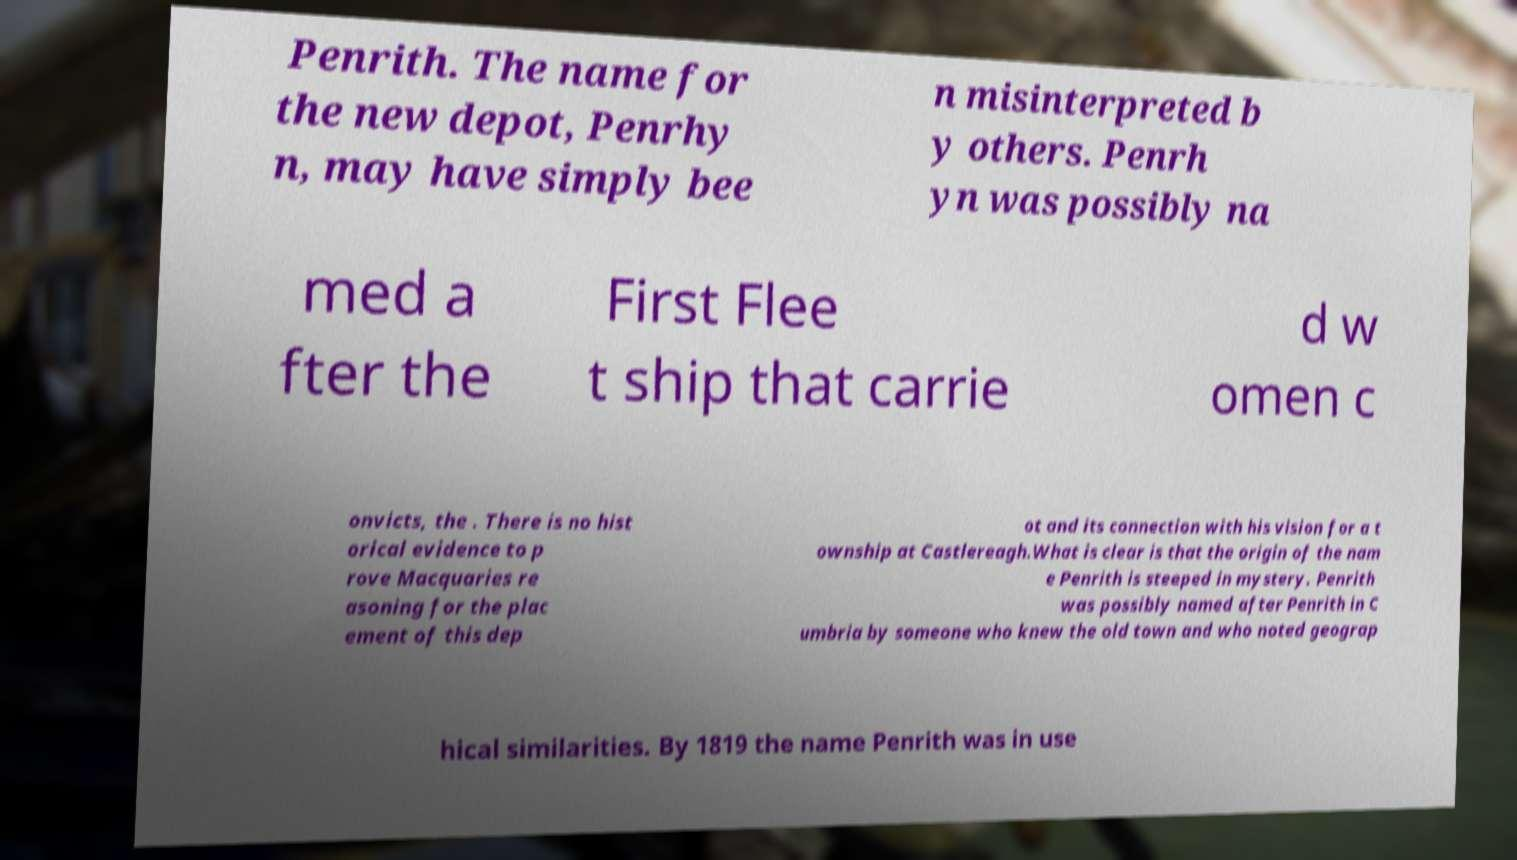What messages or text are displayed in this image? I need them in a readable, typed format. Penrith. The name for the new depot, Penrhy n, may have simply bee n misinterpreted b y others. Penrh yn was possibly na med a fter the First Flee t ship that carrie d w omen c onvicts, the . There is no hist orical evidence to p rove Macquaries re asoning for the plac ement of this dep ot and its connection with his vision for a t ownship at Castlereagh.What is clear is that the origin of the nam e Penrith is steeped in mystery. Penrith was possibly named after Penrith in C umbria by someone who knew the old town and who noted geograp hical similarities. By 1819 the name Penrith was in use 